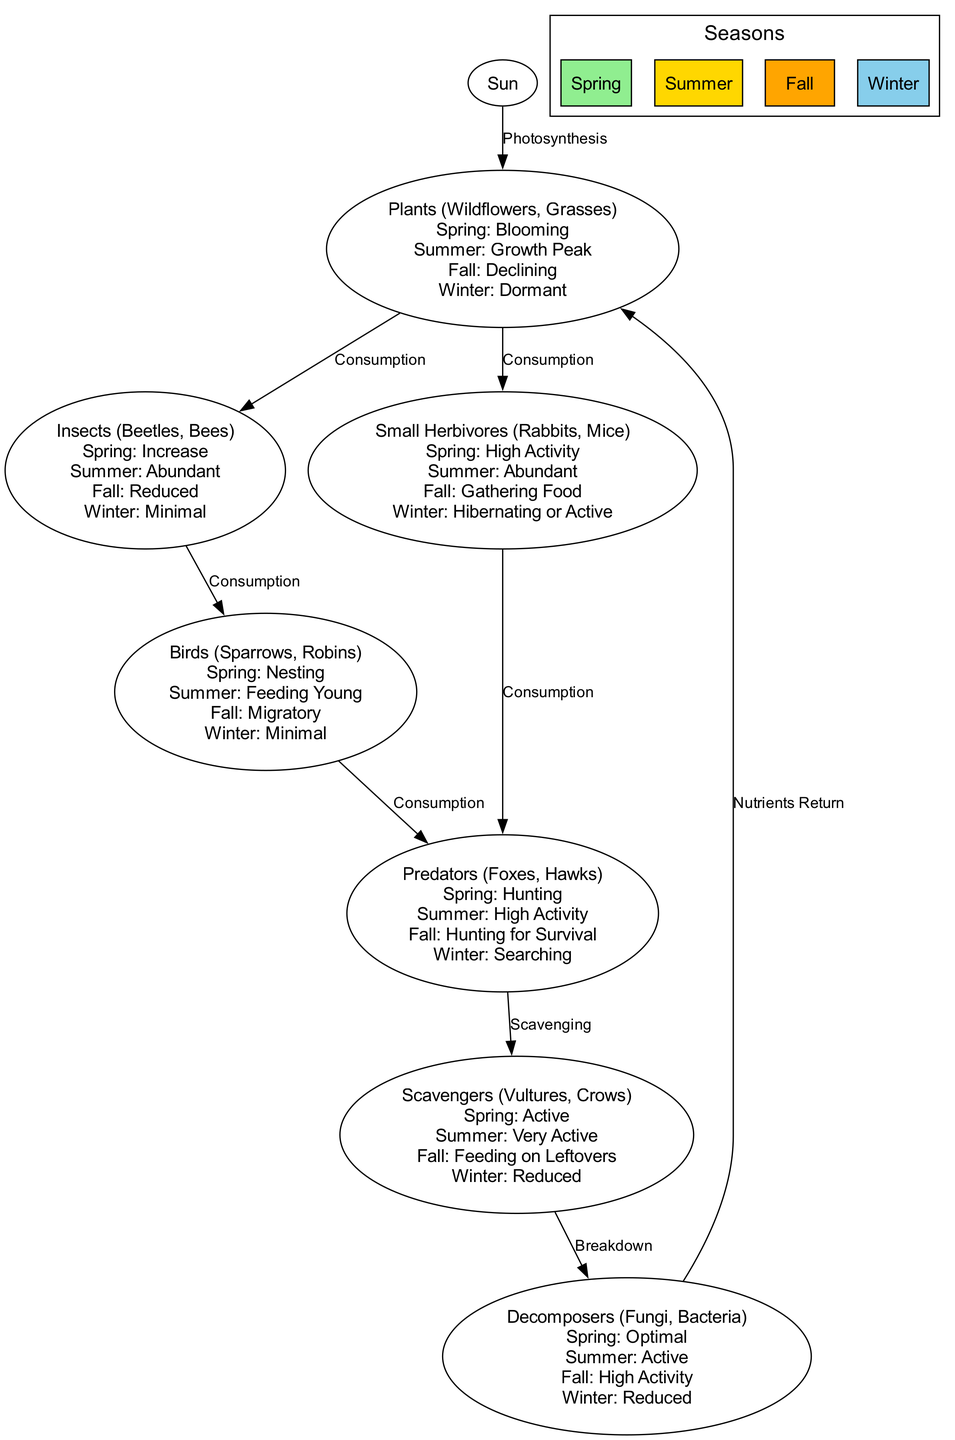What is the first node in the food chain? The first node in the food chain is "Sun," which represents the primary energy source for the ecosystem, fueling photosynthesis.
Answer: Sun How many nodes are present in the diagram? The diagram contains a total of 8 nodes, including "Sun," "Plants," "Insects," "Small Herbivores," "Birds," "Predators," "Scavengers," and "Decomposers."
Answer: 8 What is the relationship between plants and insects? The relationship is one of "Consumption," where insects consume plants as part of the food chain.
Answer: Consumption In which season are scavengers most active? Scavengers are most active in the summer season, where they are noted as "Very Active."
Answer: Summer Which node is affected by both predators and decomposers? The node affected by both predators and decomposers is "Scavengers," as they are linked to predators through scavenging and to decomposers through breakdown.
Answer: Scavengers During which season do plants bloom? Plants bloom during the spring season, as indicated by the activity "Blooming."
Answer: Spring What activity do birds engage in during spring? During spring, birds engage in "Nesting," which is a critical part of their breeding season.
Answer: Nesting Which node represents the breakdown process in the food chain? The node that represents the breakdown process in the food chain is "Decomposers," as they convert dead organic matter into nutrients.
Answer: Decomposers How do small herbivores act in fall? In fall, small herbivores are involved in "Gathering Food," indicating their preparation for winter survival.
Answer: Gathering Food 